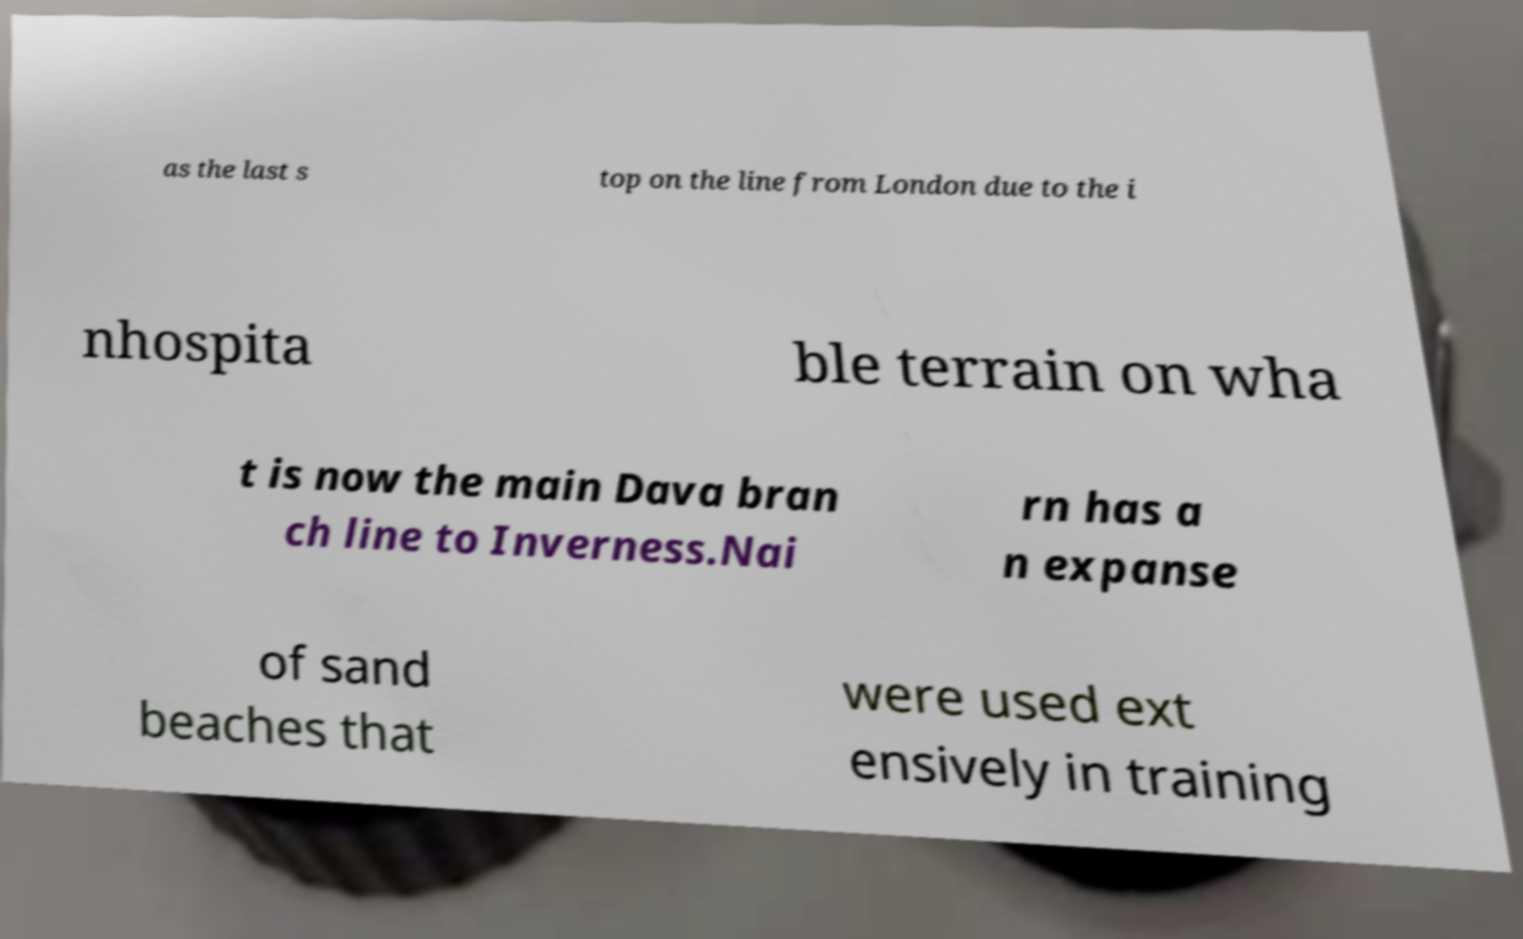There's text embedded in this image that I need extracted. Can you transcribe it verbatim? as the last s top on the line from London due to the i nhospita ble terrain on wha t is now the main Dava bran ch line to Inverness.Nai rn has a n expanse of sand beaches that were used ext ensively in training 